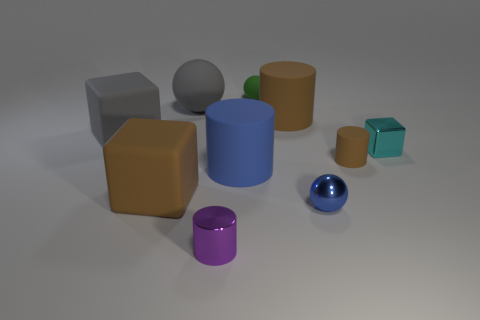Is the number of gray rubber balls that are in front of the purple metal cylinder less than the number of small cyan objects?
Provide a succinct answer. Yes. There is a blue object right of the green thing; is its size the same as the large blue thing?
Provide a short and direct response. No. How many other tiny green things have the same shape as the green rubber object?
Provide a short and direct response. 0. What size is the sphere that is made of the same material as the small purple cylinder?
Ensure brevity in your answer.  Small. Is the number of small cyan shiny things to the left of the green sphere the same as the number of big blue metallic things?
Provide a short and direct response. Yes. Does the small block have the same color as the large sphere?
Your answer should be very brief. No. Is the shape of the large brown object that is on the right side of the gray rubber sphere the same as the blue thing to the left of the tiny matte sphere?
Make the answer very short. Yes. There is another big object that is the same shape as the green rubber object; what material is it?
Provide a succinct answer. Rubber. The matte object that is both on the left side of the big blue rubber thing and behind the gray rubber cube is what color?
Ensure brevity in your answer.  Gray. There is a brown matte cylinder behind the shiny thing right of the metal ball; are there any large things that are behind it?
Ensure brevity in your answer.  Yes. 